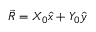<formula> <loc_0><loc_0><loc_500><loc_500>\vec { R } = X _ { 0 } \hat { x } + Y _ { 0 } \hat { y }</formula> 